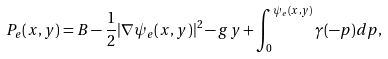Convert formula to latex. <formula><loc_0><loc_0><loc_500><loc_500>P _ { e } ( x , y ) = B - \frac { 1 } { 2 } | \nabla \psi _ { e } ( x , y ) | ^ { 2 } - g y + \int _ { 0 } ^ { \psi _ { e } ( x , y ) } \gamma ( - p ) d p ,</formula> 